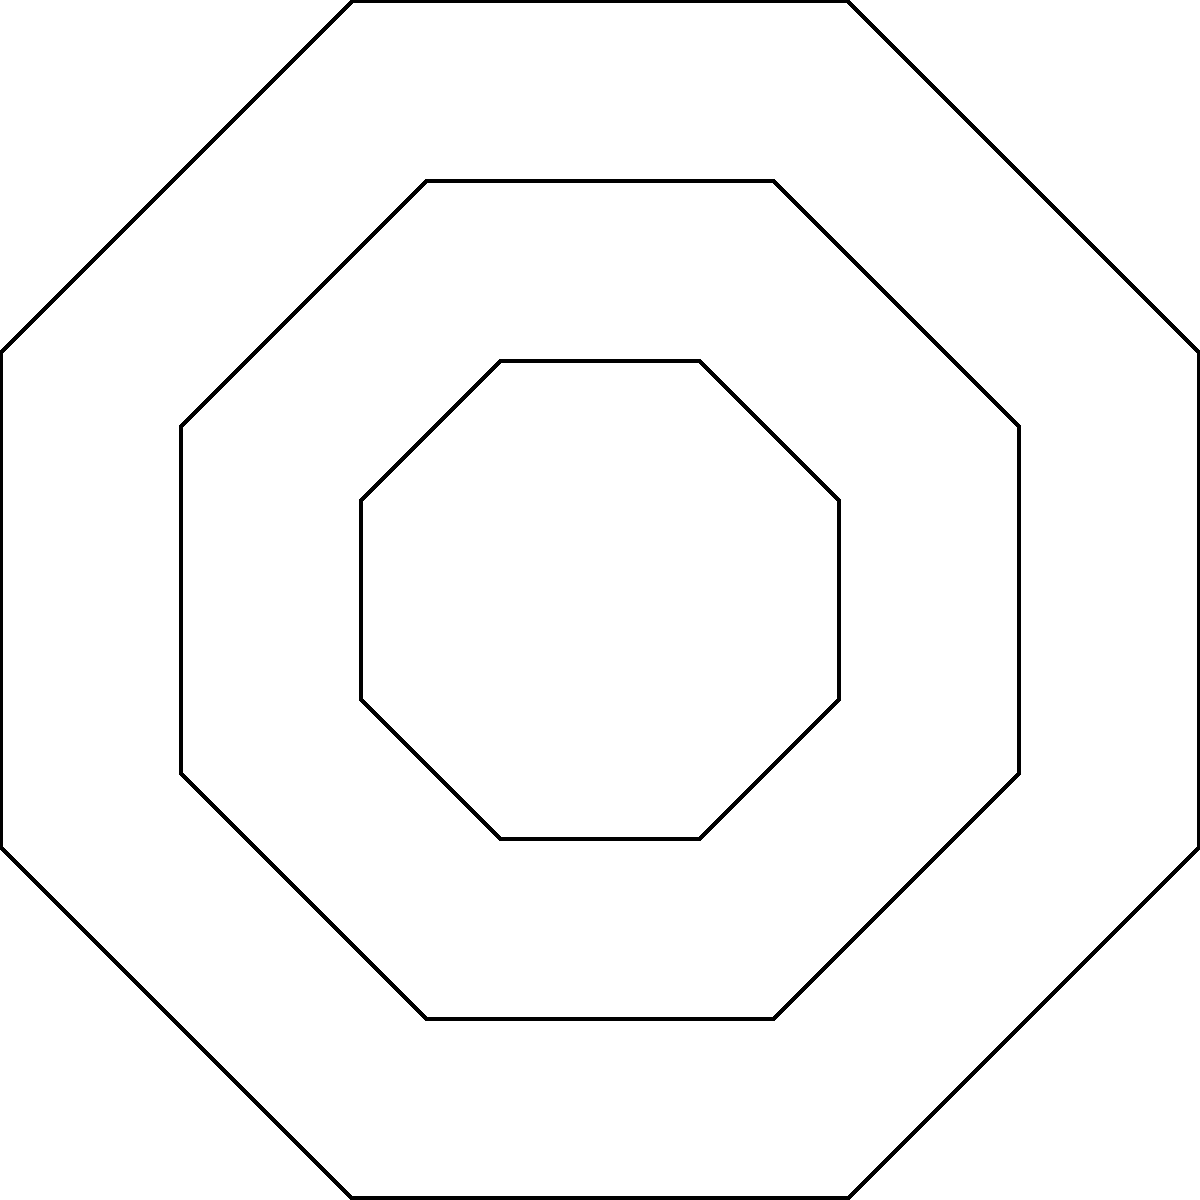In this traditional Welsh quilt pattern, how many axes of rotational symmetry does the entire design possess? To determine the number of axes of rotational symmetry in this Welsh quilt pattern, we need to follow these steps:

1. Observe the overall structure of the quilt:
   - There is a large octagon forming the outer boundary.
   - Inside, there are eight medium-sized octagons arranged in a circular pattern.
   - At the center, there are four smaller octagons.

2. Identify the rotational symmetry:
   - The quilt can be rotated by certain angles and still look the same.
   - We need to find how many times this occurs in a full 360° rotation.

3. Calculate the angle of rotation:
   - The smallest angle that produces an identical arrangement is 45°.
   - This is because the pattern repeats every 1/8 of a full rotation (360° ÷ 8 = 45°).

4. Count the number of rotational symmetries:
   - Starting from 0° and rotating by 45° each time, we get:
     0°, 45°, 90°, 135°, 180°, 225°, 270°, 315°
   - This gives us 8 positions where the pattern looks identical.

5. Conclude:
   - The number of axes of rotational symmetry is equal to the number of identical positions.
   - Therefore, the quilt pattern has 8 axes of rotational symmetry.
Answer: 8 